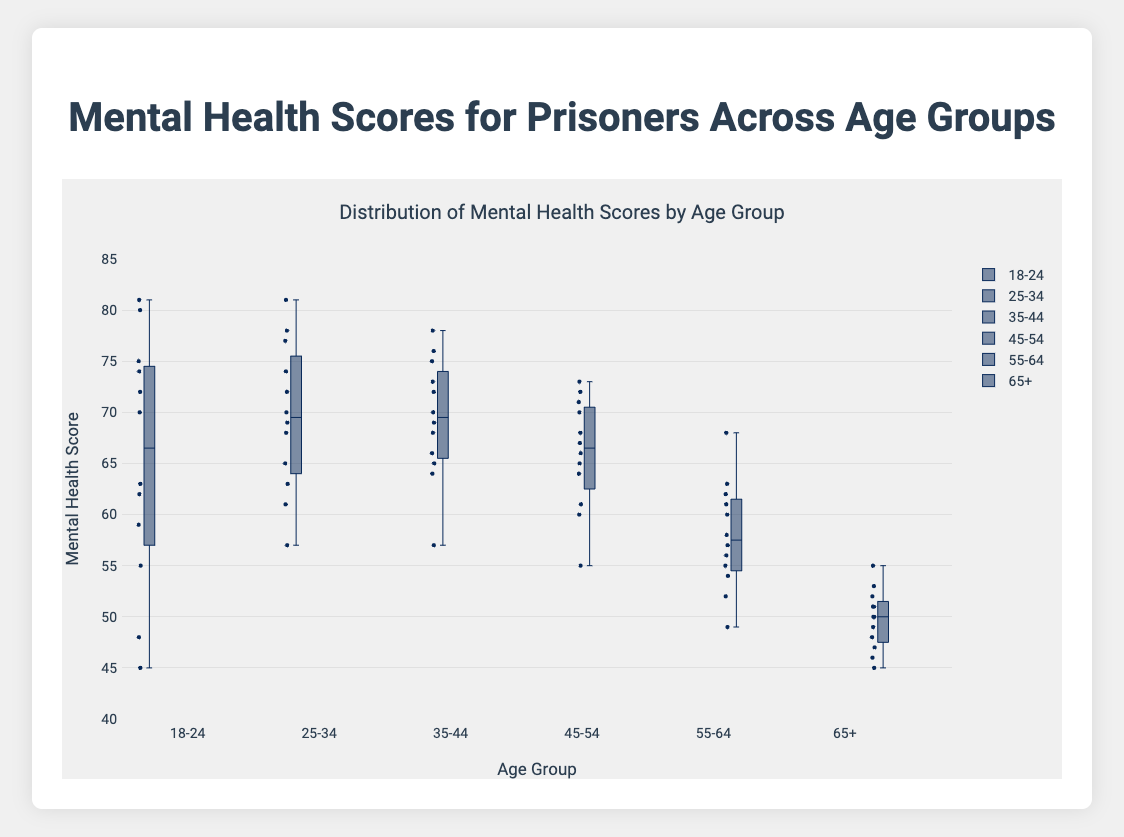What is the median mental health score for the 18-24 age group? To find the median, we need to look at the box plot's central mark, which represents the median value for the 18-24 age group.
Answer: The median is 63.5 Which age group has the widest range of mental health scores? The range is the difference between the maximum and minimum values, which can be visually assessed by the length of the box and whiskers. The 18-24 age group has the widest range, indicated by the longest whiskers.
Answer: 18-24 What is the interquartile range (IQR) for the 55-64 age group? The IQR is the difference between the 75th percentile (upper quartile) and the 25th percentile (lower quartile). For the 55-64 age group, visually assess the top and bottom parts of the box.
Answer: The IQR is approximately 9 Which age group has the highest median mental health score? The highest median value is represented by the central mark in the box at the highest position along the y-axis. This occurs in the 25-34 age group.
Answer: 25-34 How many outliers are there in the 35-44 age group? Outliers are represented by individual points outside the whiskers of the box plot. For the 35-44 age group, count the number of these points.
Answer: There are no outliers What is the approximate range of mental health scores for the 65+ age group? The range is the difference between the maximum and minimum scores, represented by the top and bottom whiskers in the box plot. Visually assess these values on the y-axis.
Answer: The range is approximately 10 Compare the medians of the 45-54 and 55-64 age groups. Which is higher? Look at the central marks of the box plots for the two age groups and compare their positions along the y-axis. The median for the 45-54 age group is higher.
Answer: 45-54 What is the maximum mental health score observed for the 18-24 age group? The maximum score is indicated by the topmost whisker for the 18-24 age group on the y-axis.
Answer: The maximum score is 81 What do the edges of the boxes represent in this box plot? The edges of the boxes in a box plot represent the 25th and 75th percentiles (the lower and upper quartiles) of the data.
Answer: 25th and 75th percentiles Which age group shows the smallest variability in mental health scores? Variability is indicated by the range and IQR (length of the box). The 65+ age group shows the smallest variability.
Answer: 65+ 